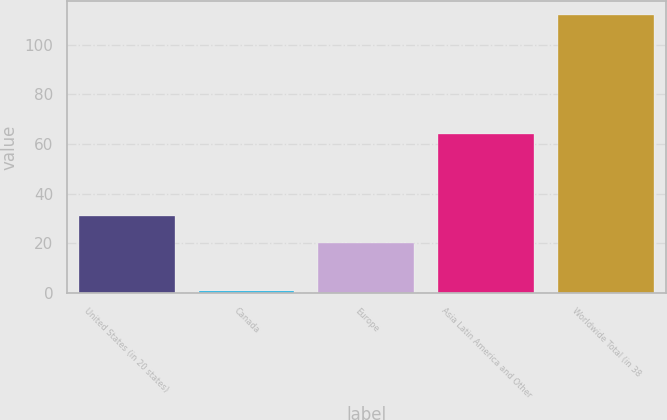Convert chart to OTSL. <chart><loc_0><loc_0><loc_500><loc_500><bar_chart><fcel>United States (in 20 states)<fcel>Canada<fcel>Europe<fcel>Asia Latin America and Other<fcel>Worldwide Total (in 38<nl><fcel>31.1<fcel>1<fcel>20<fcel>64<fcel>112<nl></chart> 